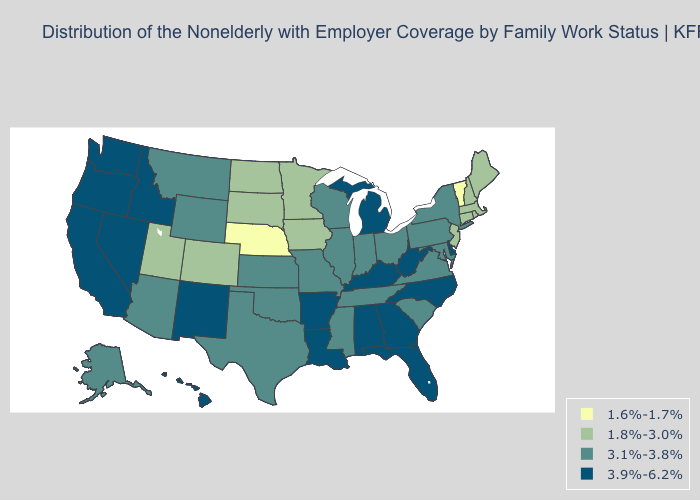What is the value of Illinois?
Give a very brief answer. 3.1%-3.8%. What is the value of South Carolina?
Give a very brief answer. 3.1%-3.8%. Does North Dakota have the highest value in the USA?
Keep it brief. No. Does the first symbol in the legend represent the smallest category?
Quick response, please. Yes. Does the map have missing data?
Short answer required. No. Name the states that have a value in the range 3.1%-3.8%?
Concise answer only. Alaska, Arizona, Illinois, Indiana, Kansas, Maryland, Mississippi, Missouri, Montana, New York, Ohio, Oklahoma, Pennsylvania, South Carolina, Tennessee, Texas, Virginia, Wisconsin, Wyoming. Name the states that have a value in the range 1.8%-3.0%?
Be succinct. Colorado, Connecticut, Iowa, Maine, Massachusetts, Minnesota, New Hampshire, New Jersey, North Dakota, Rhode Island, South Dakota, Utah. Which states hav the highest value in the West?
Short answer required. California, Hawaii, Idaho, Nevada, New Mexico, Oregon, Washington. Name the states that have a value in the range 1.6%-1.7%?
Keep it brief. Nebraska, Vermont. Name the states that have a value in the range 3.9%-6.2%?
Keep it brief. Alabama, Arkansas, California, Delaware, Florida, Georgia, Hawaii, Idaho, Kentucky, Louisiana, Michigan, Nevada, New Mexico, North Carolina, Oregon, Washington, West Virginia. What is the value of Alabama?
Concise answer only. 3.9%-6.2%. Is the legend a continuous bar?
Keep it brief. No. What is the highest value in states that border New Jersey?
Keep it brief. 3.9%-6.2%. Does the first symbol in the legend represent the smallest category?
Quick response, please. Yes. Does Utah have the highest value in the West?
Give a very brief answer. No. 